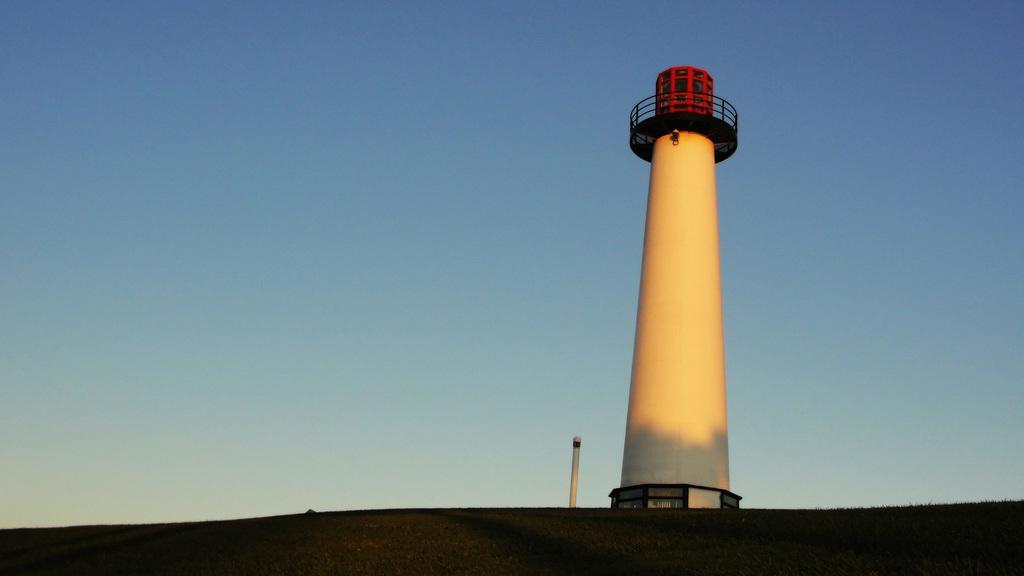Please provide a concise description of this image. In this image, we can see a lighthouse. In the background, we can see the sky. 